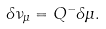Convert formula to latex. <formula><loc_0><loc_0><loc_500><loc_500>\delta { \nu } _ { \mu } = Q ^ { - } \delta \mu .</formula> 